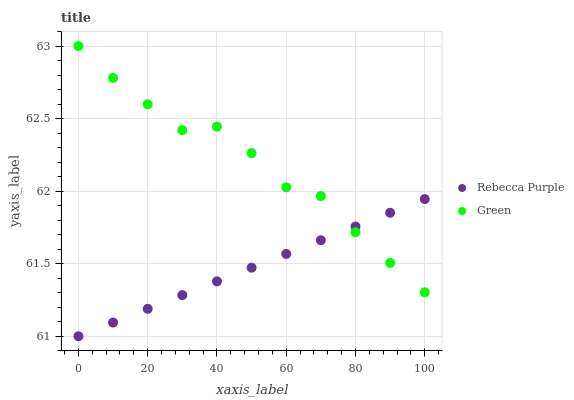Does Rebecca Purple have the minimum area under the curve?
Answer yes or no. Yes. Does Green have the maximum area under the curve?
Answer yes or no. Yes. Does Rebecca Purple have the maximum area under the curve?
Answer yes or no. No. Is Rebecca Purple the smoothest?
Answer yes or no. Yes. Is Green the roughest?
Answer yes or no. Yes. Is Rebecca Purple the roughest?
Answer yes or no. No. Does Rebecca Purple have the lowest value?
Answer yes or no. Yes. Does Green have the highest value?
Answer yes or no. Yes. Does Rebecca Purple have the highest value?
Answer yes or no. No. Does Green intersect Rebecca Purple?
Answer yes or no. Yes. Is Green less than Rebecca Purple?
Answer yes or no. No. Is Green greater than Rebecca Purple?
Answer yes or no. No. 